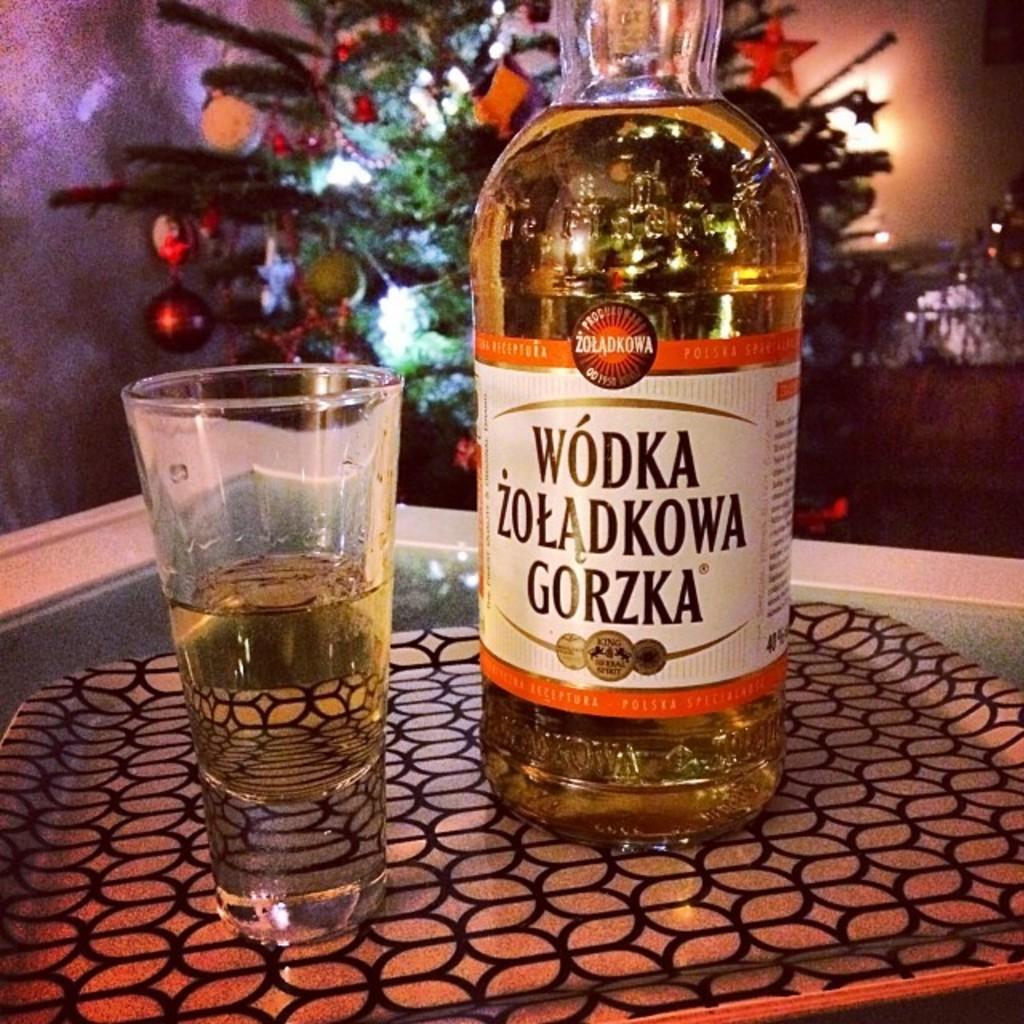What is the alcohol brand?
Provide a short and direct response. Zoladkowa. 